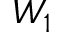Convert formula to latex. <formula><loc_0><loc_0><loc_500><loc_500>W _ { 1 }</formula> 